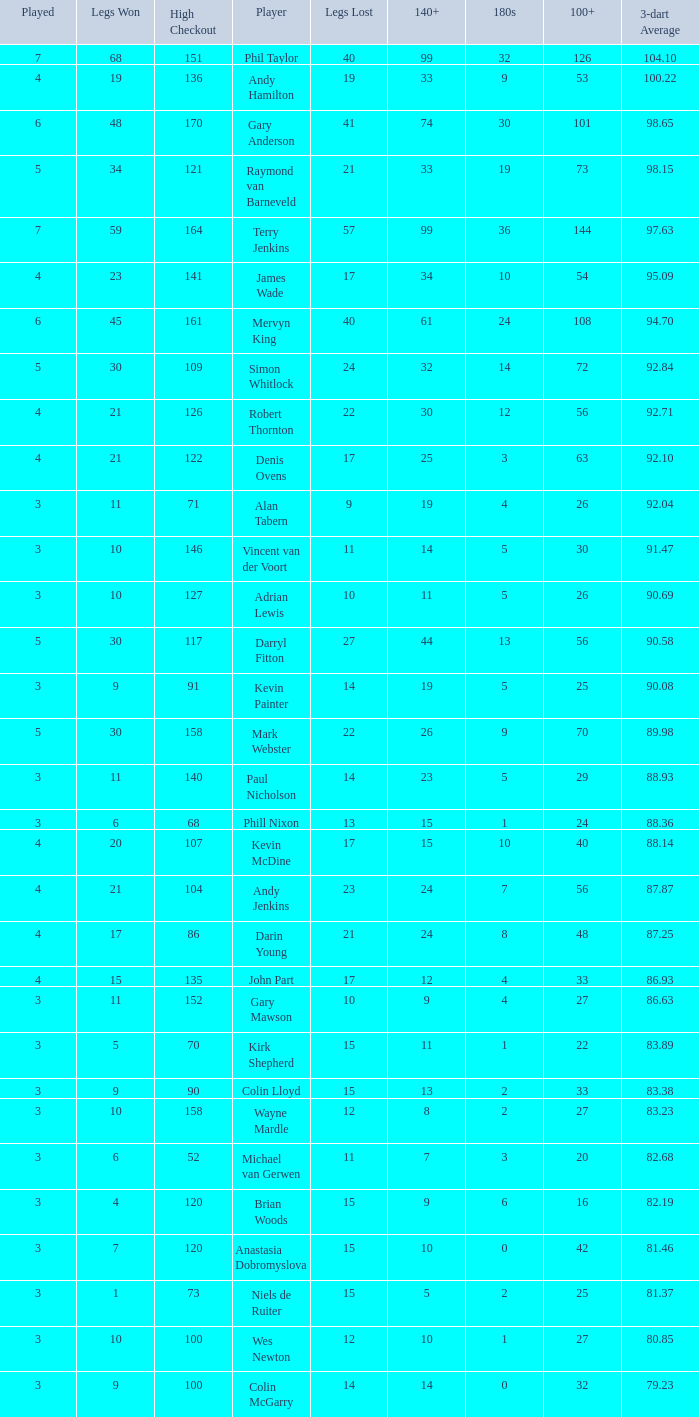What is the total number of 3-dart average when legs lost is larger than 41, and played is larger than 7? 0.0. 